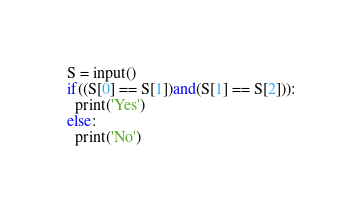Convert code to text. <code><loc_0><loc_0><loc_500><loc_500><_Python_>S = input()
if((S[0] == S[1])and(S[1] == S[2])):
  print('Yes')
else:
  print('No')</code> 